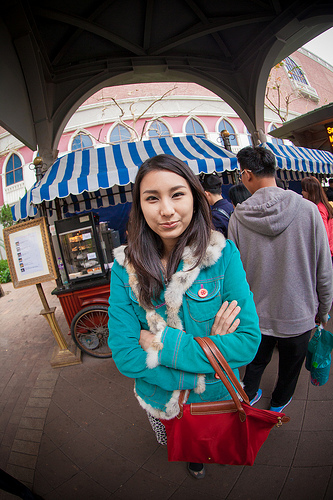<image>
Is the man behind the girl? Yes. From this viewpoint, the man is positioned behind the girl, with the girl partially or fully occluding the man. Is the women to the right of the man? No. The women is not to the right of the man. The horizontal positioning shows a different relationship. Is the trolley next to the woman? No. The trolley is not positioned next to the woman. They are located in different areas of the scene. 